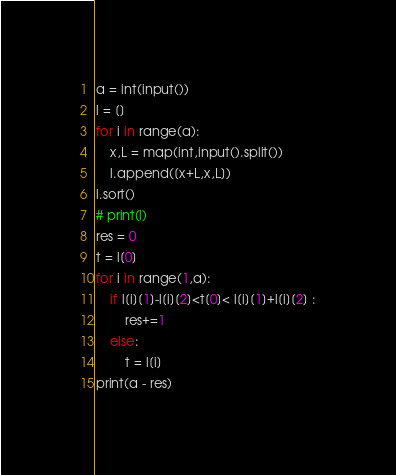<code> <loc_0><loc_0><loc_500><loc_500><_Python_>a = int(input())
l = []
for i in range(a):
    x,L = map(int,input().split())
    l.append([x+L,x,L])
l.sort()
# print(l)
res = 0
t = l[0]
for i in range(1,a):
    if l[i][1]-l[i][2]<t[0]< l[i][1]+l[i][2] :
        res+=1
    else:
        t = l[i]
print(a - res)


</code> 